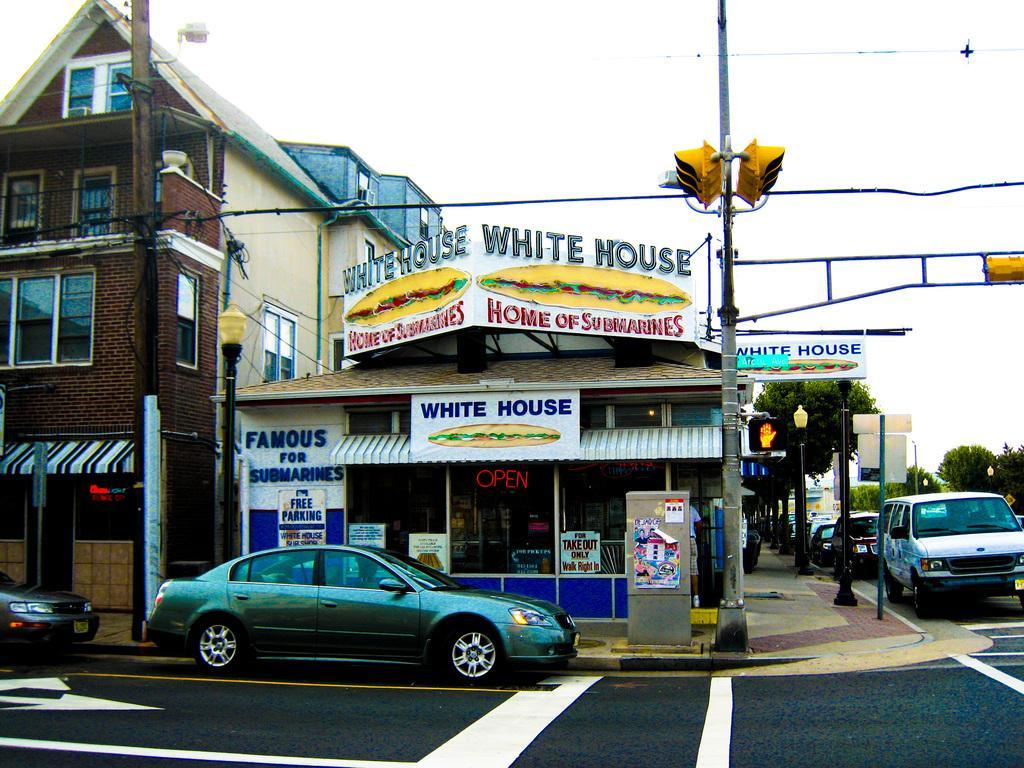In one or two sentences, can you explain what this image depicts? In front of the image there are cars on the road. There are light poles, traffic lights, electrical poles with cables, electrical box, poles, boards. In the background of the image there are buildings, trees. At the top of the image there is sky. 